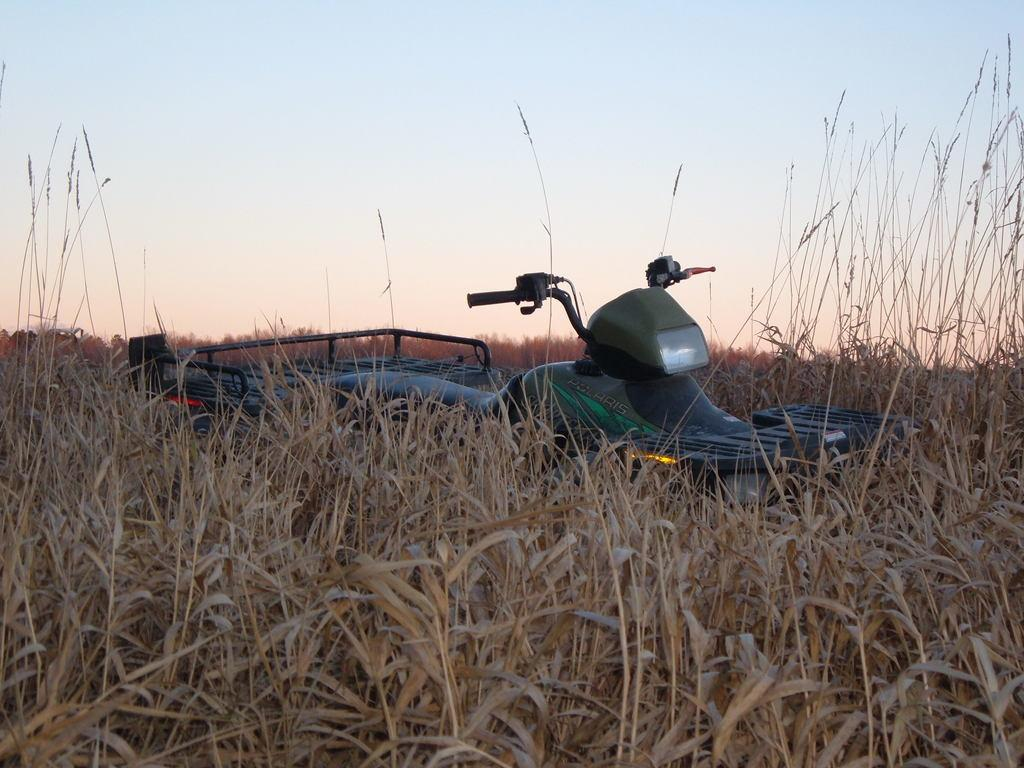What type of vegetation is present at the bottom of the image? There are plants at the bottom of the image. What can be seen in the background of the image? There is a vehicle in the background of the image. What is visible at the top of the image? The sky is visible at the top of the image. How many leaves can be seen on the flower in the image? There is no flower present in the image, only plants at the bottom. What is the rate of the vehicle in the background of the image? The image does not provide information about the speed or rate of the vehicle. 